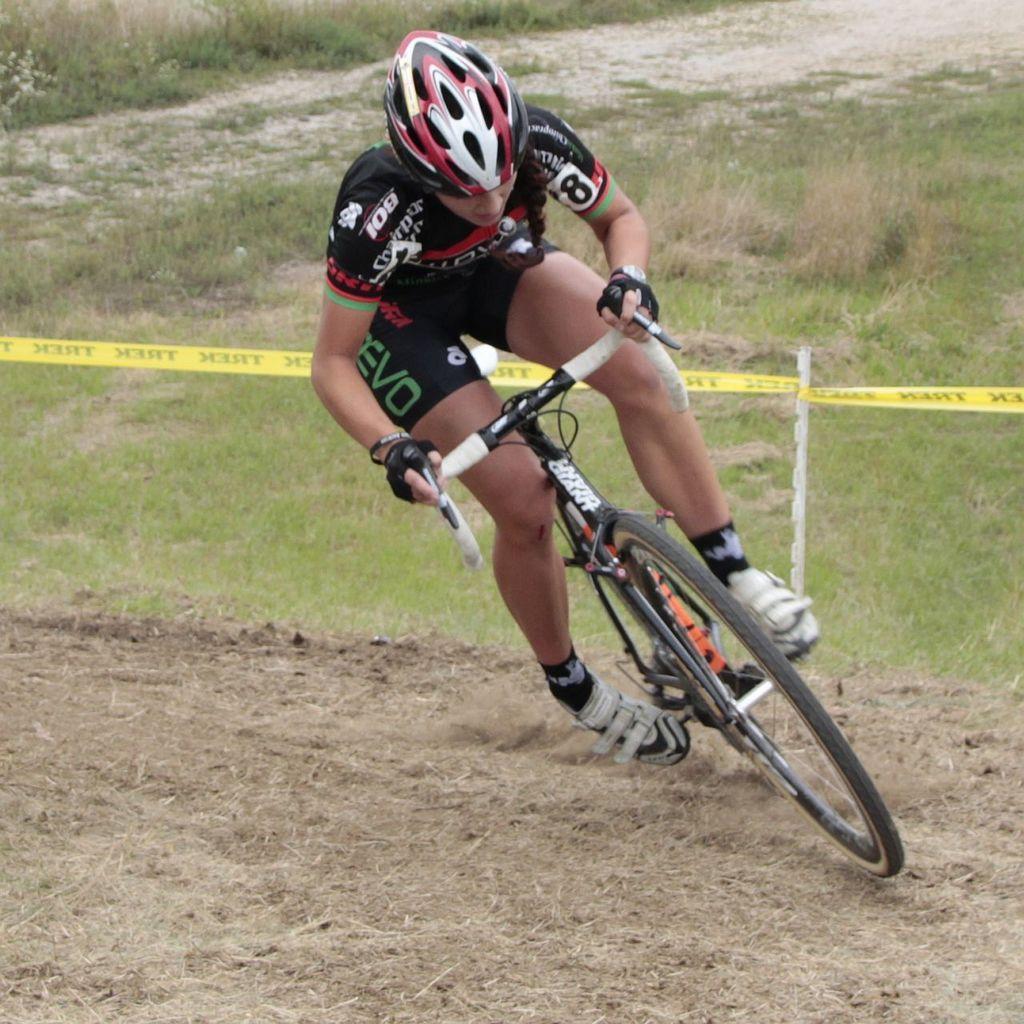How would you summarize this image in a sentence or two? There is a person in black color dress, wearing helmet and cycling on the road. In the background, there is a yellow color ribbon attached to the pole and there is grass on the ground. 